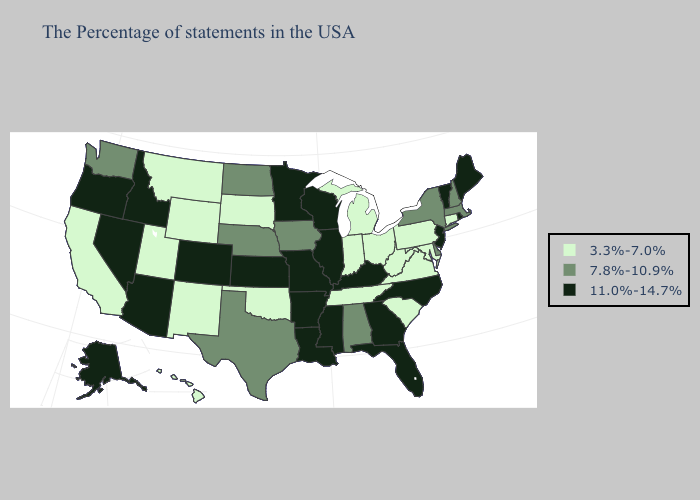What is the value of Massachusetts?
Be succinct. 7.8%-10.9%. Name the states that have a value in the range 11.0%-14.7%?
Concise answer only. Maine, Rhode Island, Vermont, New Jersey, North Carolina, Florida, Georgia, Kentucky, Wisconsin, Illinois, Mississippi, Louisiana, Missouri, Arkansas, Minnesota, Kansas, Colorado, Arizona, Idaho, Nevada, Oregon, Alaska. What is the lowest value in states that border Kansas?
Concise answer only. 3.3%-7.0%. Name the states that have a value in the range 7.8%-10.9%?
Keep it brief. Massachusetts, New Hampshire, New York, Delaware, Alabama, Iowa, Nebraska, Texas, North Dakota, Washington. Among the states that border Pennsylvania , does New York have the lowest value?
Concise answer only. No. What is the value of Washington?
Answer briefly. 7.8%-10.9%. How many symbols are there in the legend?
Write a very short answer. 3. Name the states that have a value in the range 7.8%-10.9%?
Give a very brief answer. Massachusetts, New Hampshire, New York, Delaware, Alabama, Iowa, Nebraska, Texas, North Dakota, Washington. Does the map have missing data?
Give a very brief answer. No. What is the value of South Carolina?
Short answer required. 3.3%-7.0%. Is the legend a continuous bar?
Quick response, please. No. Name the states that have a value in the range 11.0%-14.7%?
Be succinct. Maine, Rhode Island, Vermont, New Jersey, North Carolina, Florida, Georgia, Kentucky, Wisconsin, Illinois, Mississippi, Louisiana, Missouri, Arkansas, Minnesota, Kansas, Colorado, Arizona, Idaho, Nevada, Oregon, Alaska. Among the states that border Nevada , does Utah have the highest value?
Be succinct. No. Does Oklahoma have the lowest value in the USA?
Keep it brief. Yes. Name the states that have a value in the range 7.8%-10.9%?
Give a very brief answer. Massachusetts, New Hampshire, New York, Delaware, Alabama, Iowa, Nebraska, Texas, North Dakota, Washington. 